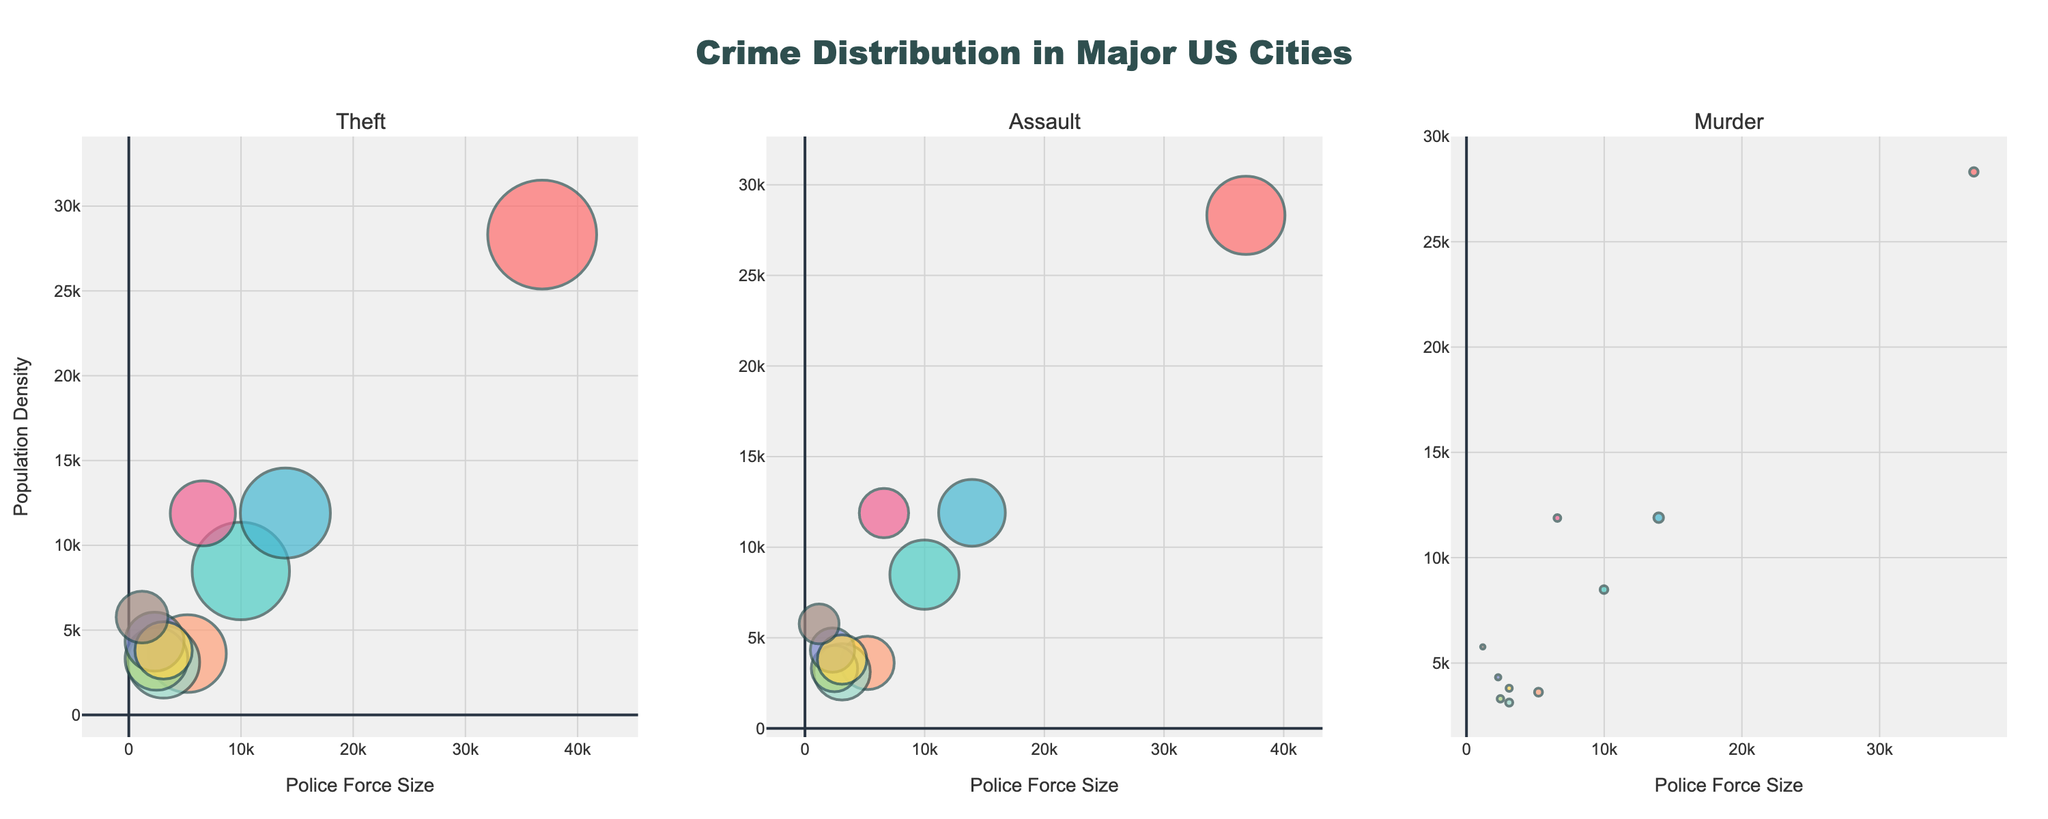What is the title of the subplot? The title of the subplot can be found at the top of the figure, which provides a brief summary of the visualization.
Answer: Crime Distribution in Major US Cities Which crime type appears in the second subplot? The subplot title indicates which crime type is being visualized in each subplot. The second subplot title is located above its respective plot area.
Answer: Assault How many total cities are represented in the figure? Each unique color in each subplot represents a different city. Counting these unique cities provides the total number of cities represented.
Answer: 10 Which city has the highest population density? In the subplot, identifying the city with the highest y-axis value (Population Density) across the subplots will determine the city with the highest population density.
Answer: New York Which crime type has the largest bubble size in any of the subplots? The bubble size represents the crime count. Observing the largest bubble across the three subplots will identify which crime type has the largest count.
Answer: Theft How does the police force size vary between New York and Los Angeles for theft cases? By looking at the x-axis values (Police Force Size) of New York and Los Angeles in the Theft subplot, we can compare their police force sizes.
Answer: Larger in New York than in Los Angeles Among the cities with theft cases, which city has the smallest police force size? In the Theft subplot, identify the bubble (city) with the smallest x-axis value, which represents the police force size.
Answer: San Jose Calculate the average population density of cities displayed in the Murder subplot. Sum the population densities of all cities in the Murder subplot and divide by the total number of cities represented in that subplot. Population Densities: 28317 + 8484 + 11900 + 3614 + 3120 + 11883 + 3300 + 4320 + 3800 + 5765. Average = (167503 / 10)
Answer: 16750.3 Which city with assault cases has the largest difference between police force size and population density? For each city in the Assault subplot, subtract population density (y-axis) from police force size (x-axis) and determine which city has the largest resulting value. Example calculations for each city are needed to identify the largest difference.
Answer: New York Identify the city with the highest number of murders. Locate the largest bubble in the Murder subplot, as the bubble size represents the crime count.
Answer: Chicago 